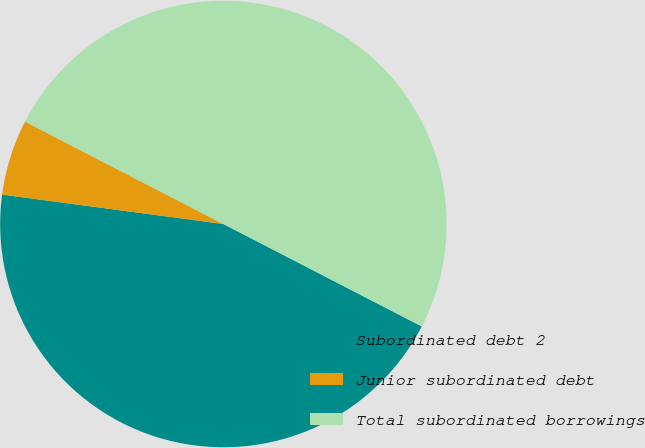Convert chart to OTSL. <chart><loc_0><loc_0><loc_500><loc_500><pie_chart><fcel>Subordinated debt 2<fcel>Junior subordinated debt<fcel>Total subordinated borrowings<nl><fcel>44.52%<fcel>5.48%<fcel>50.0%<nl></chart> 